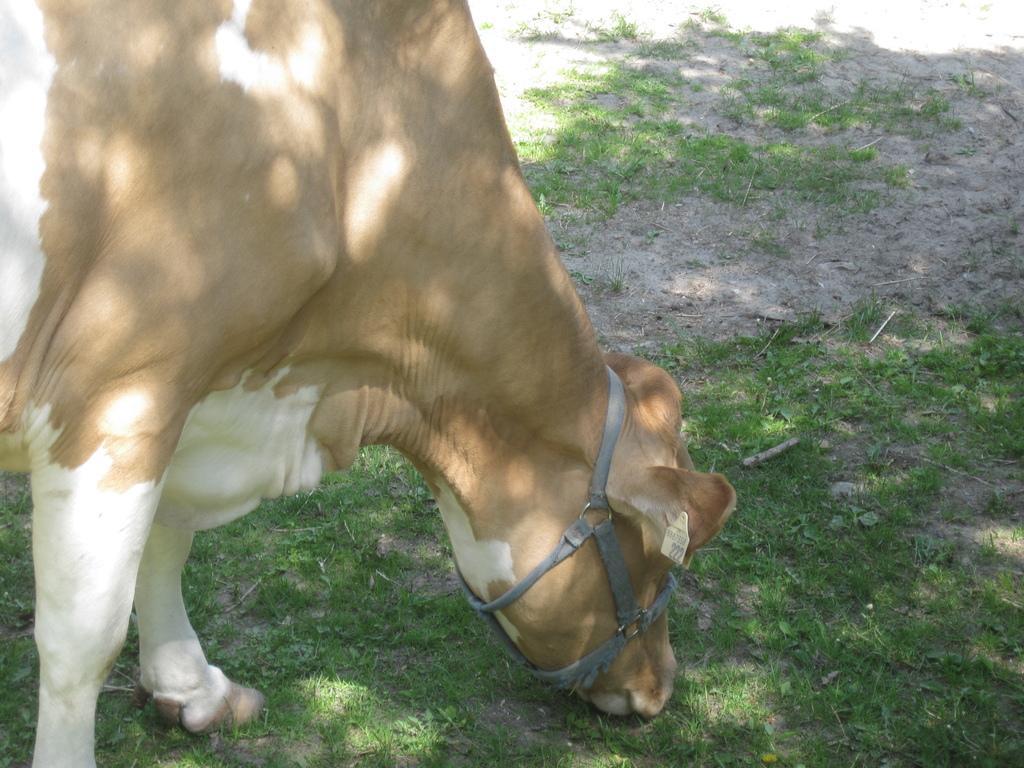Can you describe this image briefly? In this picture there is a brown and white color cow, eating grass from the ground. 